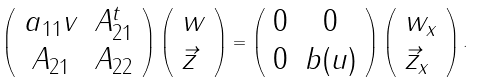<formula> <loc_0><loc_0><loc_500><loc_500>\left ( \begin{array} { c c } a _ { 1 1 } v & A _ { 2 1 } ^ { t } \\ A _ { 2 1 } & A _ { 2 2 } \\ \end{array} \right ) \left ( \begin{array} { l l } w \\ \vec { z } \\ \end{array} \right ) = \left ( \begin{array} { c c } 0 & 0 \\ 0 & b ( u ) \\ \end{array} \right ) \left ( \begin{array} { l l } w _ { x } \\ \vec { z } _ { x } \\ \end{array} \right ) .</formula> 